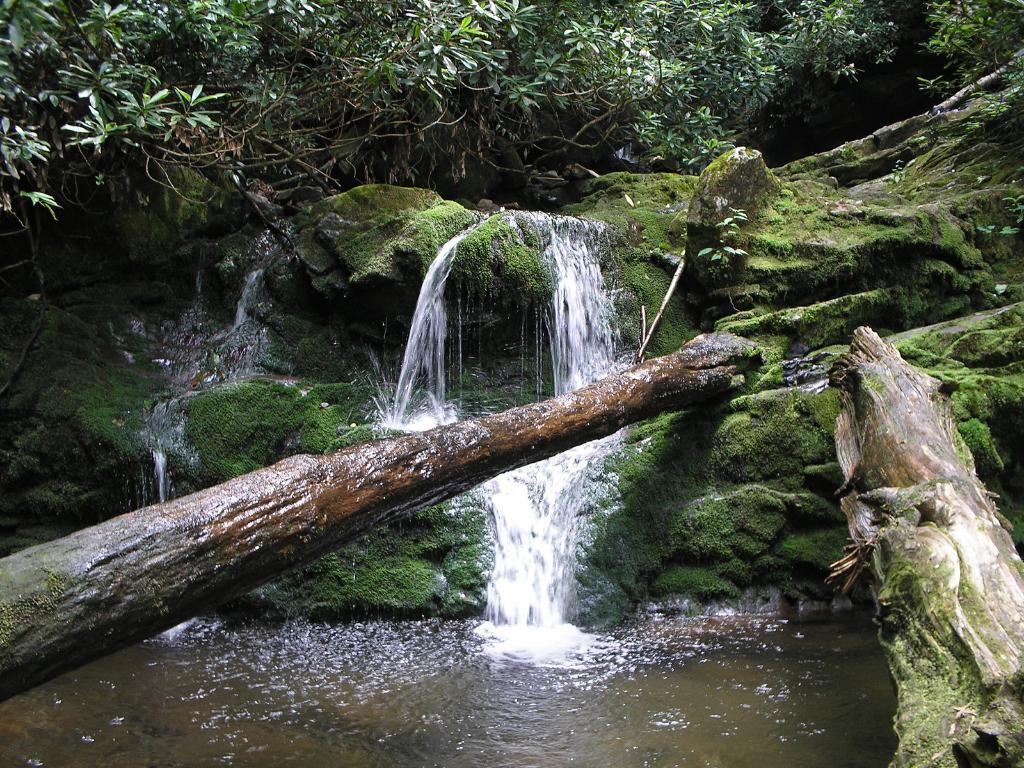What type of natural objects can be seen in the image? There are tree trunks in the image. What is the body of water visible in the image? There is water visible in the image. What type of vegetation is present in the image? There is grass in the image. What can be seen in the background of the image? There are trees in the background of the image. What type of music can be heard playing in the background of the image? There is no music present in the image, as it is a still photograph. 